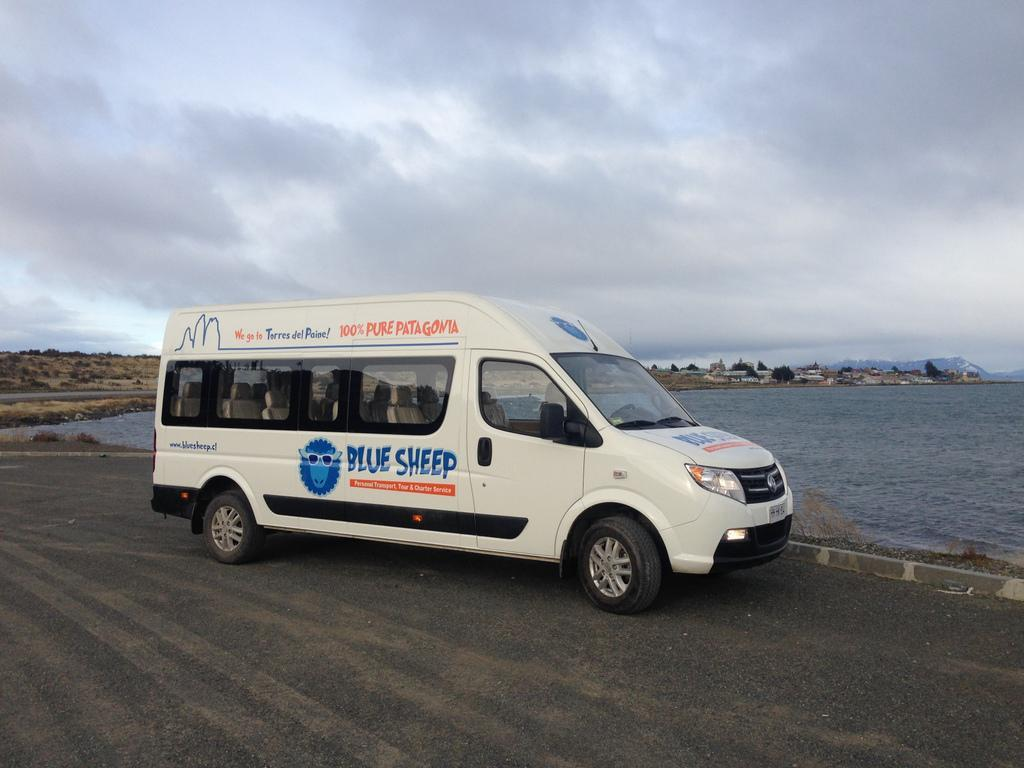<image>
Write a terse but informative summary of the picture. White and blue van which says "Blue Sheep" on it. 